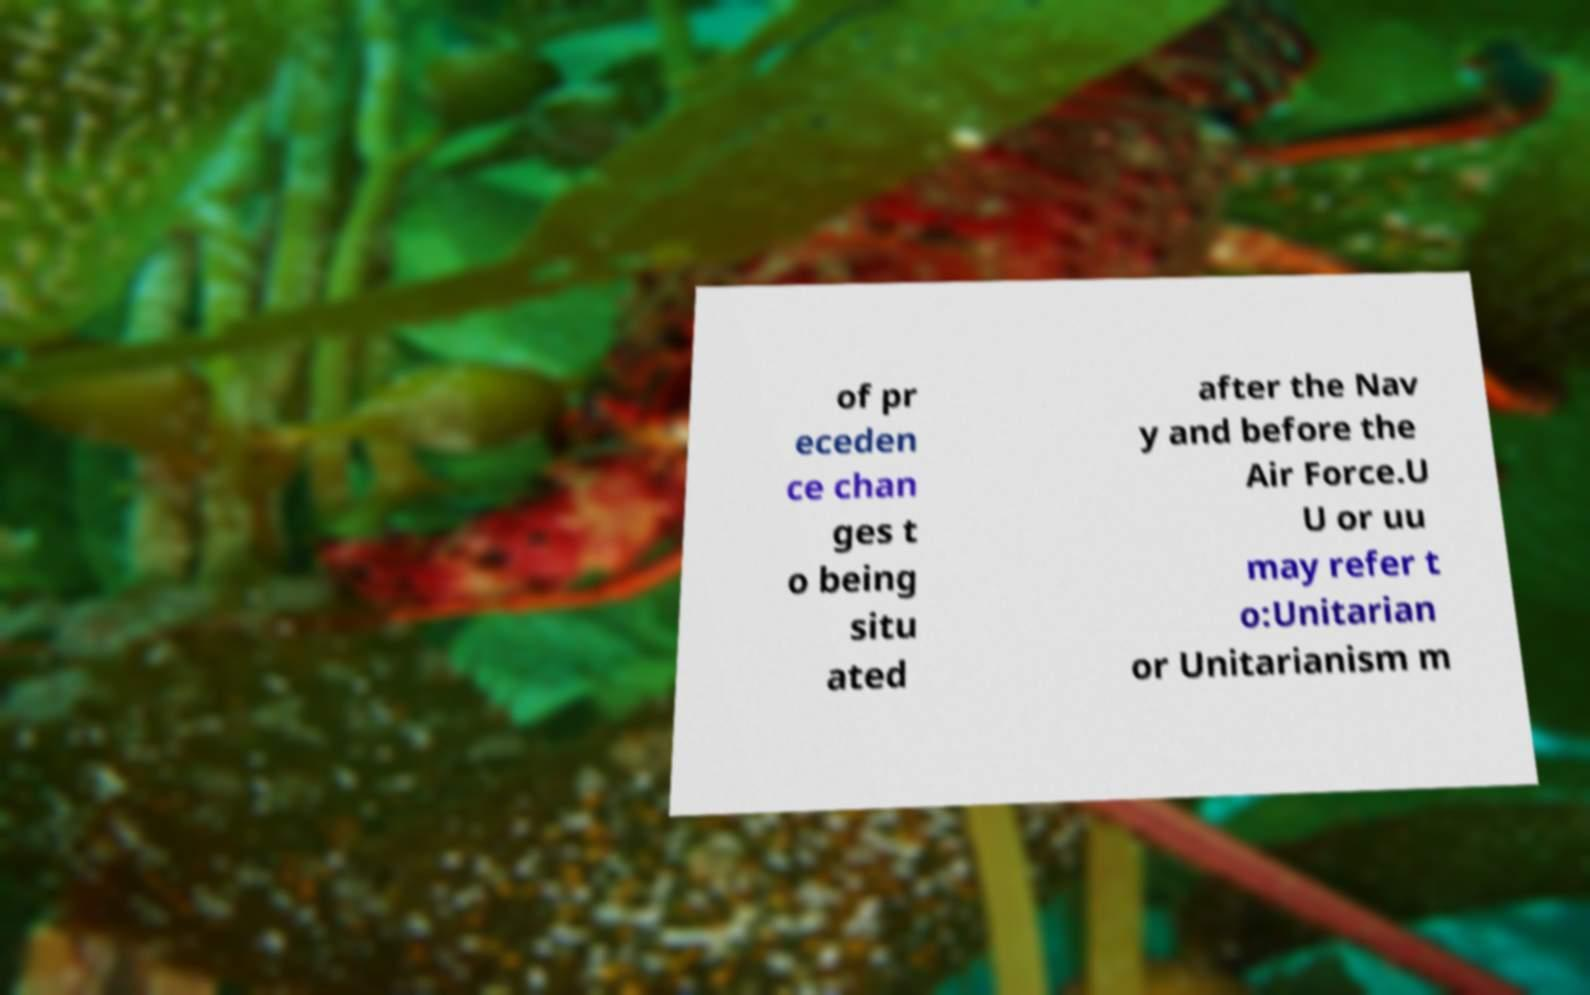Can you read and provide the text displayed in the image?This photo seems to have some interesting text. Can you extract and type it out for me? of pr eceden ce chan ges t o being situ ated after the Nav y and before the Air Force.U U or uu may refer t o:Unitarian or Unitarianism m 